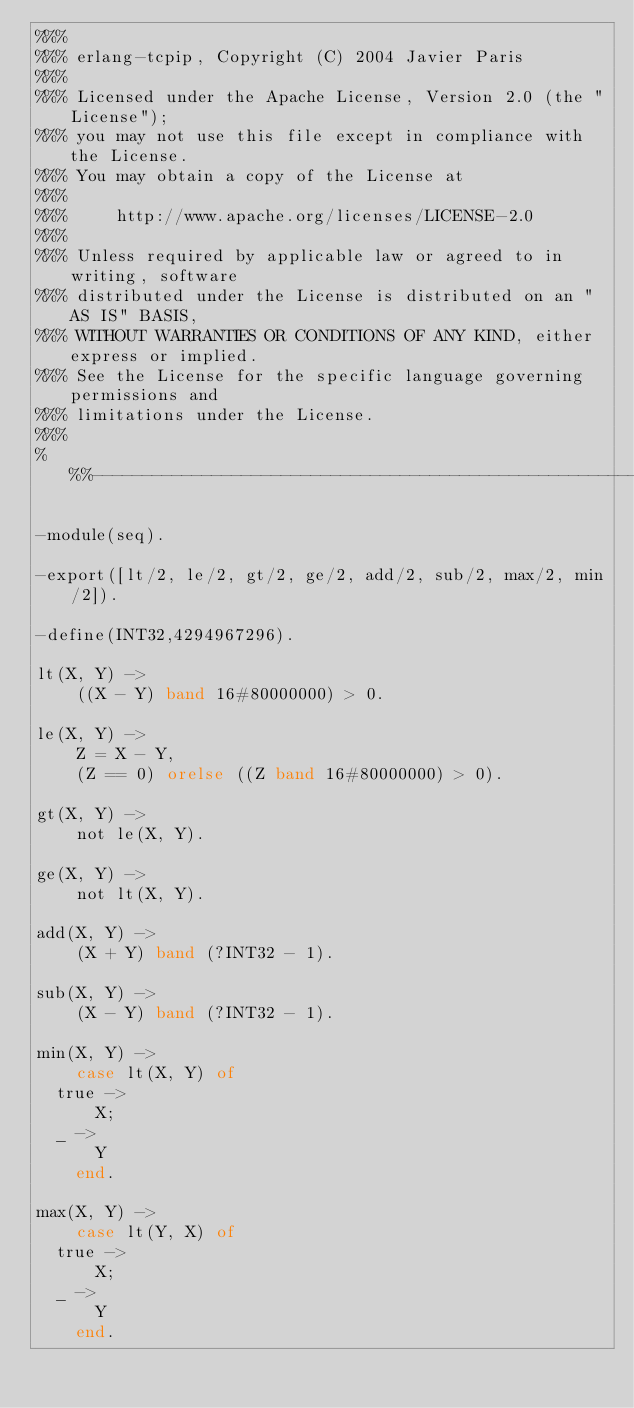Convert code to text. <code><loc_0><loc_0><loc_500><loc_500><_Erlang_>%%%
%%% erlang-tcpip, Copyright (C) 2004 Javier Paris
%%%
%%% Licensed under the Apache License, Version 2.0 (the "License");
%%% you may not use this file except in compliance with the License.
%%% You may obtain a copy of the License at
%%%
%%%     http://www.apache.org/licenses/LICENSE-2.0
%%%
%%% Unless required by applicable law or agreed to in writing, software
%%% distributed under the License is distributed on an "AS IS" BASIS,
%%% WITHOUT WARRANTIES OR CONDITIONS OF ANY KIND, either express or implied.
%%% See the License for the specific language governing permissions and
%%% limitations under the License.
%%%
%%%-------------------------------------------------------------------

-module(seq).

-export([lt/2, le/2, gt/2, ge/2, add/2, sub/2, max/2, min/2]).

-define(INT32,4294967296).

lt(X, Y) ->
    ((X - Y) band 16#80000000) > 0.

le(X, Y) ->
    Z = X - Y,
    (Z == 0) orelse ((Z band 16#80000000) > 0).

gt(X, Y) ->
    not le(X, Y).

ge(X, Y) ->
    not lt(X, Y).

add(X, Y) ->
    (X + Y) band (?INT32 - 1).

sub(X, Y) ->
    (X - Y) band (?INT32 - 1).

min(X, Y) ->
    case lt(X, Y) of
	true ->
	    X;
	_ ->
	    Y
    end.

max(X, Y) ->
    case lt(Y, X) of
	true ->
	    X;
	_ ->
	    Y
    end.
		  
</code> 